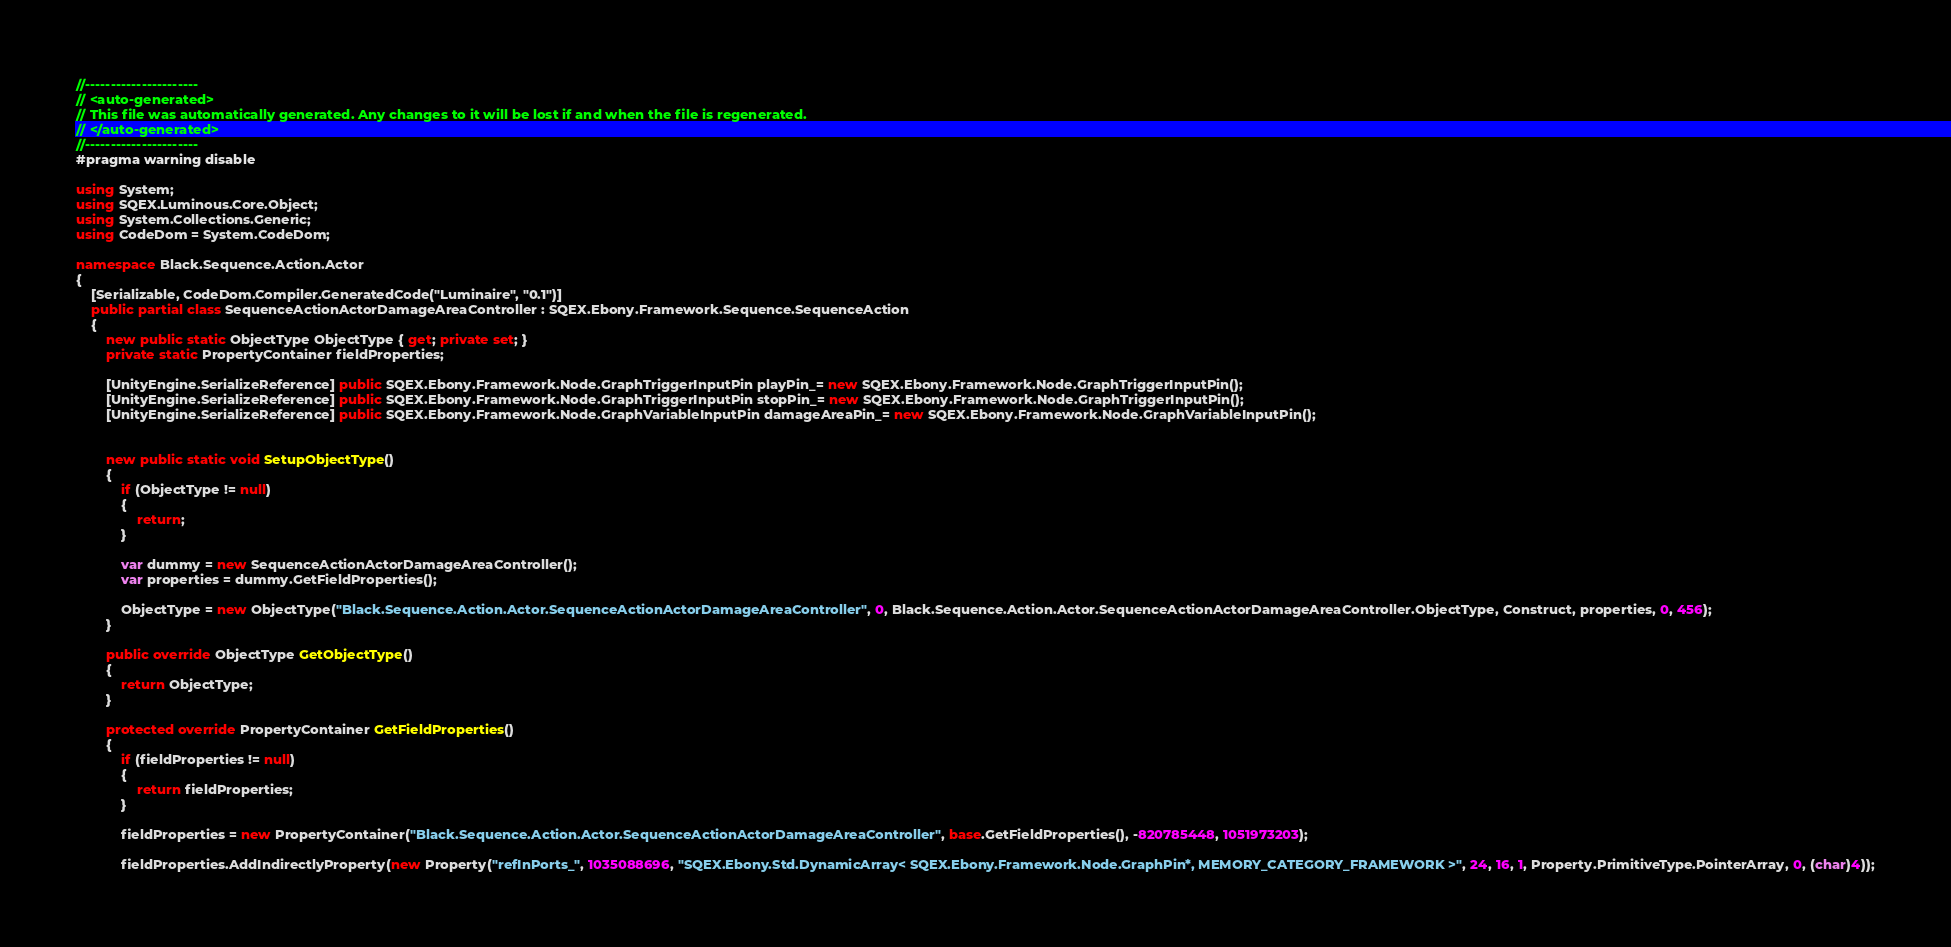Convert code to text. <code><loc_0><loc_0><loc_500><loc_500><_C#_>//----------------------
// <auto-generated>
// This file was automatically generated. Any changes to it will be lost if and when the file is regenerated.
// </auto-generated>
//----------------------
#pragma warning disable

using System;
using SQEX.Luminous.Core.Object;
using System.Collections.Generic;
using CodeDom = System.CodeDom;

namespace Black.Sequence.Action.Actor
{
    [Serializable, CodeDom.Compiler.GeneratedCode("Luminaire", "0.1")]
    public partial class SequenceActionActorDamageAreaController : SQEX.Ebony.Framework.Sequence.SequenceAction
    {
        new public static ObjectType ObjectType { get; private set; }
        private static PropertyContainer fieldProperties;
		
		[UnityEngine.SerializeReference] public SQEX.Ebony.Framework.Node.GraphTriggerInputPin playPin_= new SQEX.Ebony.Framework.Node.GraphTriggerInputPin();
		[UnityEngine.SerializeReference] public SQEX.Ebony.Framework.Node.GraphTriggerInputPin stopPin_= new SQEX.Ebony.Framework.Node.GraphTriggerInputPin();
		[UnityEngine.SerializeReference] public SQEX.Ebony.Framework.Node.GraphVariableInputPin damageAreaPin_= new SQEX.Ebony.Framework.Node.GraphVariableInputPin();
		
        
        new public static void SetupObjectType()
        {
            if (ObjectType != null)
            {
                return;
            }

            var dummy = new SequenceActionActorDamageAreaController();
            var properties = dummy.GetFieldProperties();

            ObjectType = new ObjectType("Black.Sequence.Action.Actor.SequenceActionActorDamageAreaController", 0, Black.Sequence.Action.Actor.SequenceActionActorDamageAreaController.ObjectType, Construct, properties, 0, 456);
        }
		
        public override ObjectType GetObjectType()
        {
            return ObjectType;
        }

        protected override PropertyContainer GetFieldProperties()
        {
            if (fieldProperties != null)
            {
                return fieldProperties;
            }

            fieldProperties = new PropertyContainer("Black.Sequence.Action.Actor.SequenceActionActorDamageAreaController", base.GetFieldProperties(), -820785448, 1051973203);
            
			fieldProperties.AddIndirectlyProperty(new Property("refInPorts_", 1035088696, "SQEX.Ebony.Std.DynamicArray< SQEX.Ebony.Framework.Node.GraphPin*, MEMORY_CATEGORY_FRAMEWORK >", 24, 16, 1, Property.PrimitiveType.PointerArray, 0, (char)4));</code> 